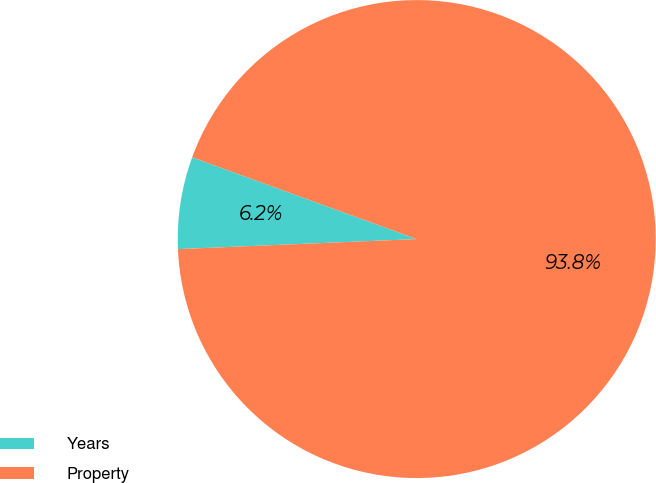<chart> <loc_0><loc_0><loc_500><loc_500><pie_chart><fcel>Years<fcel>Property<nl><fcel>6.23%<fcel>93.77%<nl></chart> 